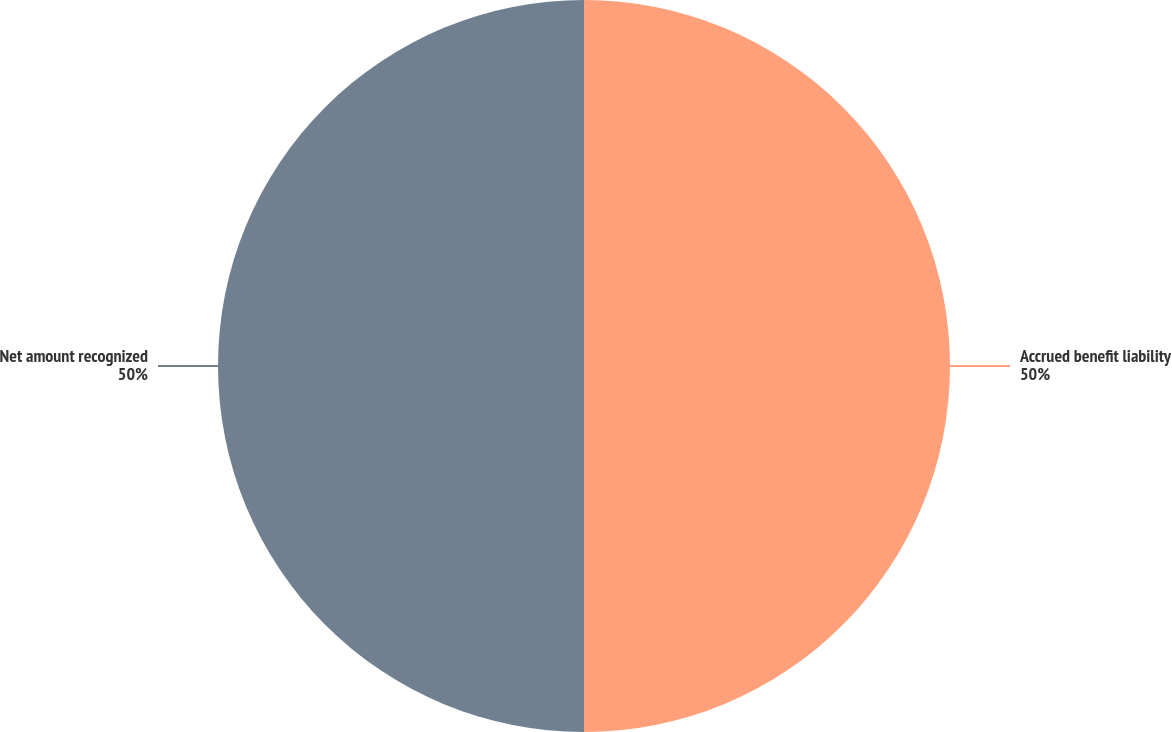<chart> <loc_0><loc_0><loc_500><loc_500><pie_chart><fcel>Accrued benefit liability<fcel>Net amount recognized<nl><fcel>50.0%<fcel>50.0%<nl></chart> 